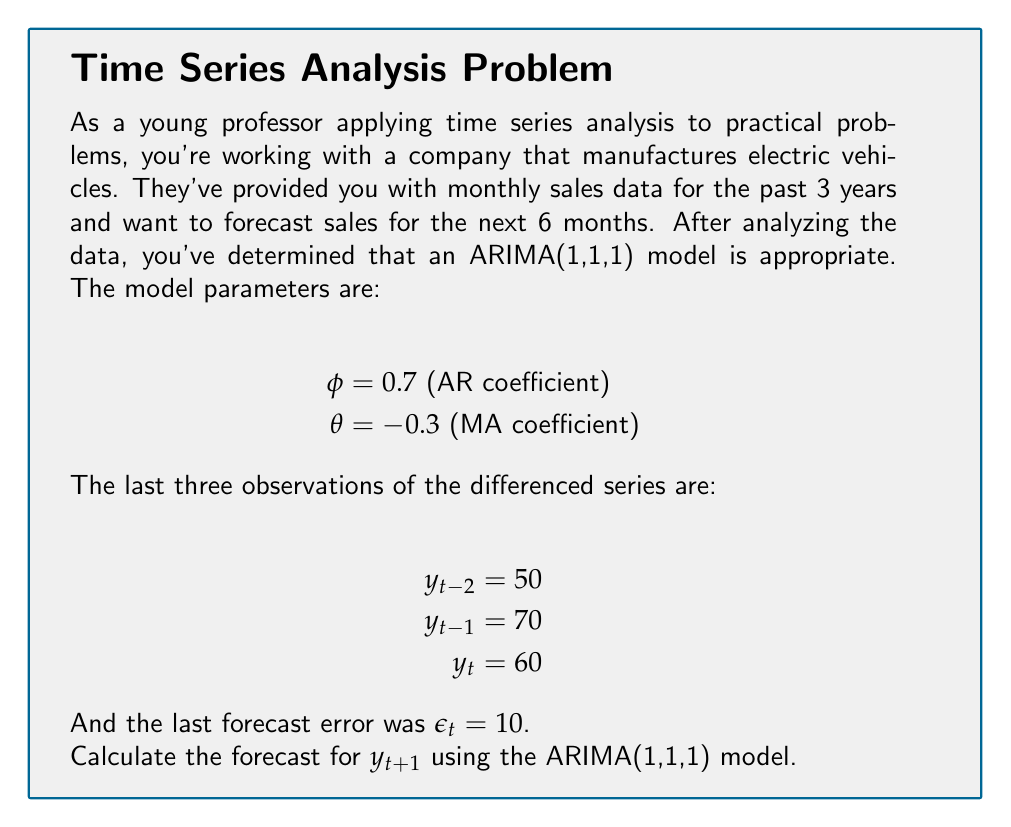Provide a solution to this math problem. To solve this problem, we'll follow these steps:

1) Recall the general form of an ARIMA(1,1,1) model:

   $$(1-\phi B)(1-B)Y_t = (1+\theta B)\epsilon_t$$

   where $B$ is the backshift operator.

2) For forecasting, we use the form:

   $$\hat{Y}_{t+1} = Y_t + \phi(Y_t - Y_{t-1}) + \theta\epsilon_t$$

3) Since we're working with the differenced series, we need to use:

   $$\hat{y}_{t+1} = \phi y_t + \theta\epsilon_t$$

4) Substituting the given values:

   $$\hat{y}_{t+1} = 0.7(60) + (-0.3)(10)$$

5) Calculating:

   $$\hat{y}_{t+1} = 42 - 3 = 39$$

6) However, this is the forecast for the differenced series. To get the actual forecast, we need to add this to the last observed value:

   $$\hat{Y}_{t+1} = Y_t + \hat{y}_{t+1}$$

7) We don't have $Y_t$ directly, but we can calculate it:

   $$Y_t = Y_{t-1} + y_t = Y_{t-1} + 60$$

8) Similarly, $Y_{t-1} = Y_{t-2} + y_{t-1} = Y_{t-2} + 70$

9) Therefore:

   $$Y_t = Y_{t-2} + 70 + 60 = Y_{t-2} + 130$$

10) The final forecast is:

    $$\hat{Y}_{t+1} = Y_t + \hat{y}_{t+1} = (Y_{t-2} + 130) + 39 = Y_{t-2} + 169$$
Answer: $Y_{t-2} + 169$ 